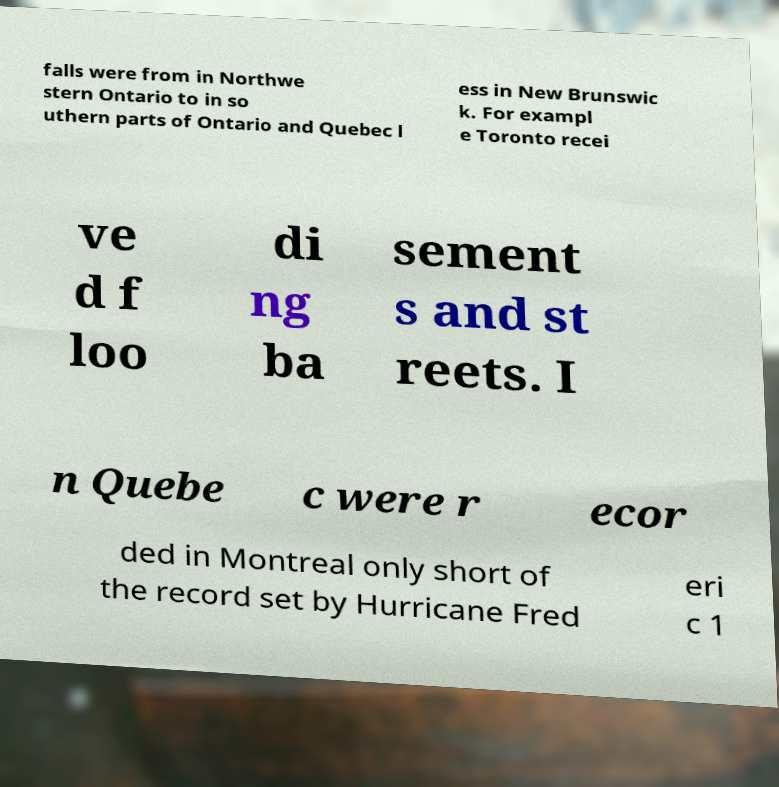Can you accurately transcribe the text from the provided image for me? falls were from in Northwe stern Ontario to in so uthern parts of Ontario and Quebec l ess in New Brunswic k. For exampl e Toronto recei ve d f loo di ng ba sement s and st reets. I n Quebe c were r ecor ded in Montreal only short of the record set by Hurricane Fred eri c 1 